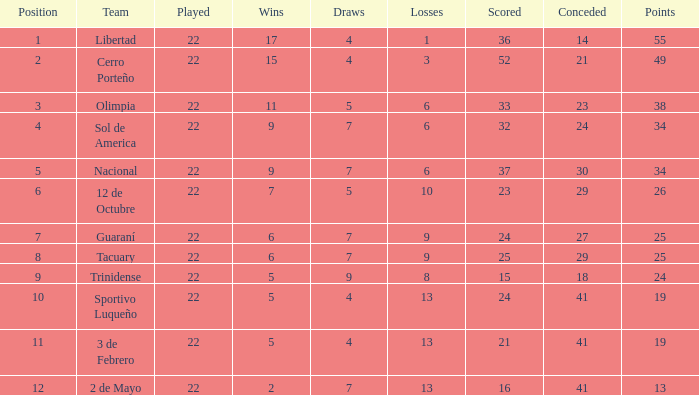What is the number of draws for the team with more than 8 losses and 13 points? 7.0. 